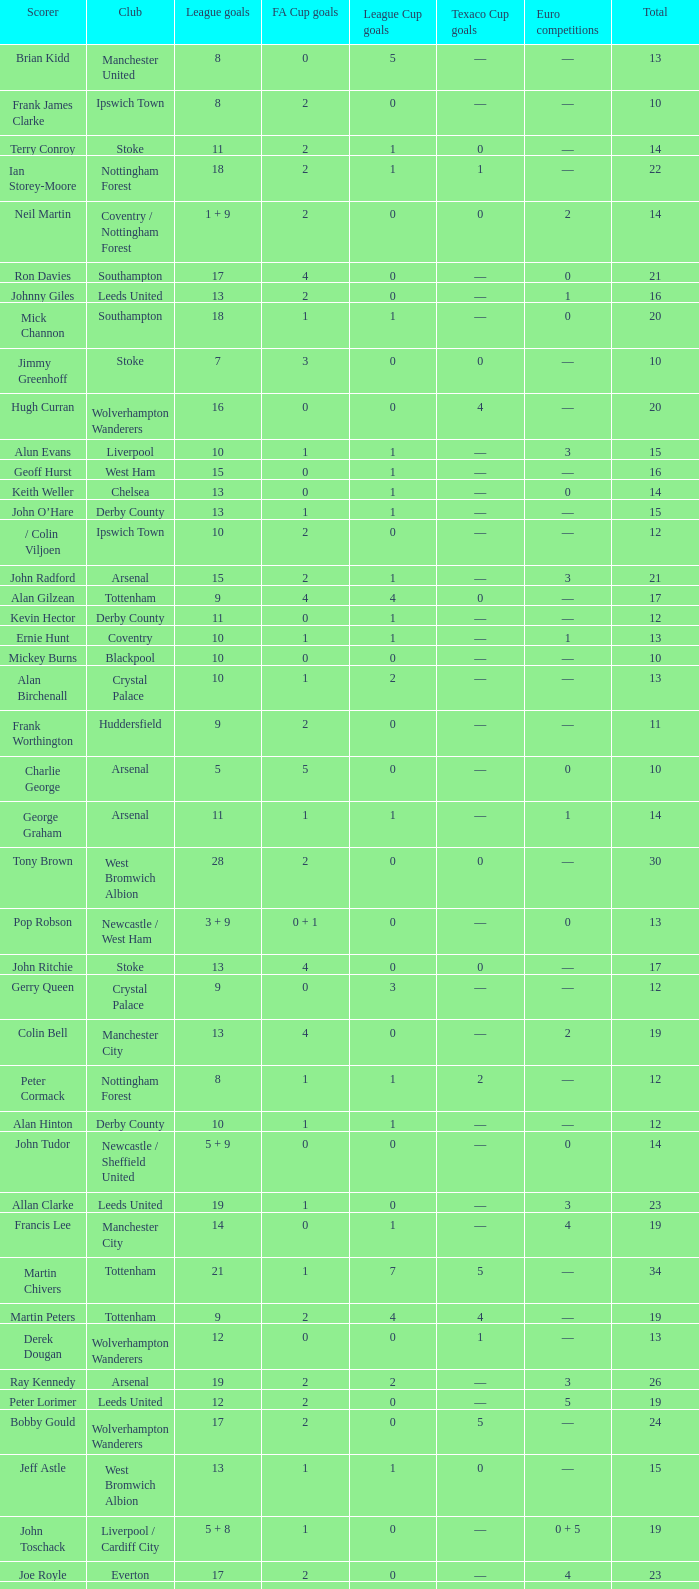What is the average Total, when FA Cup Goals is 1, when League Goals is 10, and when Club is Crystal Palace? 13.0. 